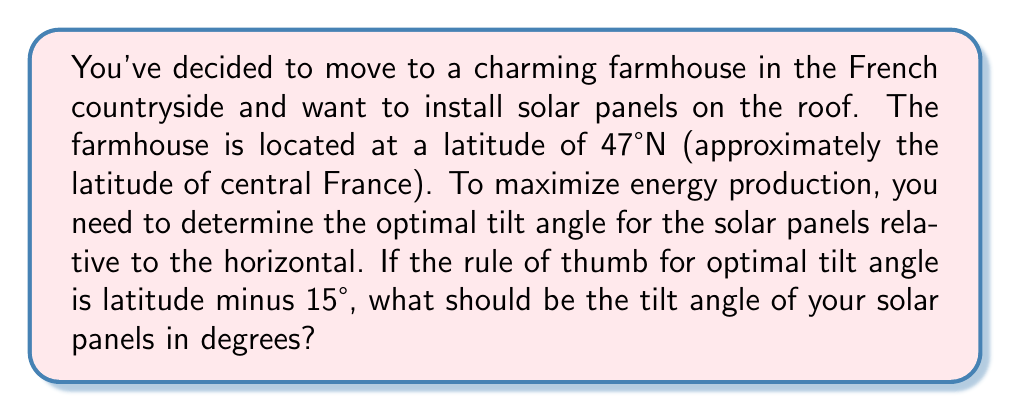Could you help me with this problem? Let's approach this step-by-step:

1) We are given that the farmhouse is located at a latitude of 47°N.

2) The rule of thumb for optimal tilt angle is:
   $$ \text{Optimal Tilt Angle} = \text{Latitude} - 15° $$

3) Substituting the given latitude into the formula:
   $$ \text{Optimal Tilt Angle} = 47° - 15° $$

4) Performing the subtraction:
   $$ \text{Optimal Tilt Angle} = 32° $$

Therefore, the optimal tilt angle for the solar panels on your farmhouse roof should be 32° relative to the horizontal.

[asy]
import geometry;

size(200);
draw((0,0)--(100,0), arrow=Arrow);
draw((0,0)--(0,100), arrow=Arrow);
draw((0,0)--(100,53.2), arrow=Arrow);

label("Horizontal", (50,-10));
label("Vertical", (-10,50));
label("Solar Panel", (70,40));

draw(arc((0,0),20,0,32), arrow=Arrow);
label("32°", (15,10));
[/asy]
Answer: 32° 